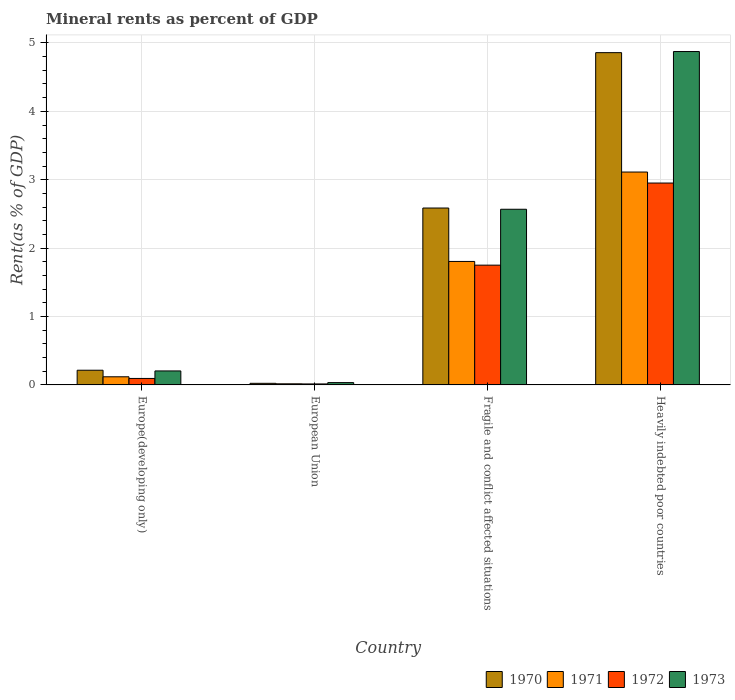How many bars are there on the 3rd tick from the left?
Your answer should be very brief. 4. What is the label of the 1st group of bars from the left?
Offer a terse response. Europe(developing only). What is the mineral rent in 1972 in Fragile and conflict affected situations?
Offer a terse response. 1.75. Across all countries, what is the maximum mineral rent in 1971?
Provide a succinct answer. 3.11. Across all countries, what is the minimum mineral rent in 1973?
Ensure brevity in your answer.  0.03. In which country was the mineral rent in 1970 maximum?
Provide a succinct answer. Heavily indebted poor countries. In which country was the mineral rent in 1972 minimum?
Make the answer very short. European Union. What is the total mineral rent in 1971 in the graph?
Make the answer very short. 5.05. What is the difference between the mineral rent in 1971 in Fragile and conflict affected situations and that in Heavily indebted poor countries?
Keep it short and to the point. -1.31. What is the difference between the mineral rent in 1970 in European Union and the mineral rent in 1972 in Europe(developing only)?
Provide a succinct answer. -0.07. What is the average mineral rent in 1973 per country?
Your response must be concise. 1.92. What is the difference between the mineral rent of/in 1971 and mineral rent of/in 1972 in Heavily indebted poor countries?
Your answer should be compact. 0.16. In how many countries, is the mineral rent in 1971 greater than 2.2 %?
Provide a short and direct response. 1. What is the ratio of the mineral rent in 1972 in Europe(developing only) to that in Heavily indebted poor countries?
Provide a succinct answer. 0.03. What is the difference between the highest and the second highest mineral rent in 1971?
Your answer should be very brief. -1.69. What is the difference between the highest and the lowest mineral rent in 1970?
Your response must be concise. 4.83. What does the 3rd bar from the left in Fragile and conflict affected situations represents?
Offer a terse response. 1972. How many bars are there?
Your response must be concise. 16. Are all the bars in the graph horizontal?
Provide a short and direct response. No. What is the difference between two consecutive major ticks on the Y-axis?
Offer a terse response. 1. Does the graph contain any zero values?
Offer a very short reply. No. Where does the legend appear in the graph?
Offer a very short reply. Bottom right. How many legend labels are there?
Provide a succinct answer. 4. What is the title of the graph?
Your response must be concise. Mineral rents as percent of GDP. Does "1996" appear as one of the legend labels in the graph?
Provide a succinct answer. No. What is the label or title of the Y-axis?
Offer a very short reply. Rent(as % of GDP). What is the Rent(as % of GDP) of 1970 in Europe(developing only)?
Your answer should be very brief. 0.21. What is the Rent(as % of GDP) of 1971 in Europe(developing only)?
Give a very brief answer. 0.12. What is the Rent(as % of GDP) of 1972 in Europe(developing only)?
Give a very brief answer. 0.09. What is the Rent(as % of GDP) of 1973 in Europe(developing only)?
Ensure brevity in your answer.  0.2. What is the Rent(as % of GDP) of 1970 in European Union?
Your answer should be very brief. 0.02. What is the Rent(as % of GDP) in 1971 in European Union?
Offer a terse response. 0.02. What is the Rent(as % of GDP) in 1972 in European Union?
Your answer should be compact. 0.01. What is the Rent(as % of GDP) of 1973 in European Union?
Ensure brevity in your answer.  0.03. What is the Rent(as % of GDP) of 1970 in Fragile and conflict affected situations?
Keep it short and to the point. 2.59. What is the Rent(as % of GDP) in 1971 in Fragile and conflict affected situations?
Keep it short and to the point. 1.81. What is the Rent(as % of GDP) in 1972 in Fragile and conflict affected situations?
Offer a terse response. 1.75. What is the Rent(as % of GDP) of 1973 in Fragile and conflict affected situations?
Keep it short and to the point. 2.57. What is the Rent(as % of GDP) in 1970 in Heavily indebted poor countries?
Keep it short and to the point. 4.86. What is the Rent(as % of GDP) of 1971 in Heavily indebted poor countries?
Provide a short and direct response. 3.11. What is the Rent(as % of GDP) in 1972 in Heavily indebted poor countries?
Provide a short and direct response. 2.95. What is the Rent(as % of GDP) of 1973 in Heavily indebted poor countries?
Your answer should be very brief. 4.87. Across all countries, what is the maximum Rent(as % of GDP) in 1970?
Your answer should be compact. 4.86. Across all countries, what is the maximum Rent(as % of GDP) of 1971?
Give a very brief answer. 3.11. Across all countries, what is the maximum Rent(as % of GDP) of 1972?
Offer a terse response. 2.95. Across all countries, what is the maximum Rent(as % of GDP) of 1973?
Your answer should be compact. 4.87. Across all countries, what is the minimum Rent(as % of GDP) in 1970?
Keep it short and to the point. 0.02. Across all countries, what is the minimum Rent(as % of GDP) in 1971?
Offer a very short reply. 0.02. Across all countries, what is the minimum Rent(as % of GDP) in 1972?
Make the answer very short. 0.01. Across all countries, what is the minimum Rent(as % of GDP) of 1973?
Keep it short and to the point. 0.03. What is the total Rent(as % of GDP) of 1970 in the graph?
Your answer should be very brief. 7.68. What is the total Rent(as % of GDP) in 1971 in the graph?
Keep it short and to the point. 5.05. What is the total Rent(as % of GDP) of 1972 in the graph?
Offer a very short reply. 4.81. What is the total Rent(as % of GDP) in 1973 in the graph?
Make the answer very short. 7.68. What is the difference between the Rent(as % of GDP) in 1970 in Europe(developing only) and that in European Union?
Keep it short and to the point. 0.19. What is the difference between the Rent(as % of GDP) in 1971 in Europe(developing only) and that in European Union?
Give a very brief answer. 0.1. What is the difference between the Rent(as % of GDP) in 1972 in Europe(developing only) and that in European Union?
Your answer should be compact. 0.08. What is the difference between the Rent(as % of GDP) in 1973 in Europe(developing only) and that in European Union?
Your answer should be very brief. 0.17. What is the difference between the Rent(as % of GDP) of 1970 in Europe(developing only) and that in Fragile and conflict affected situations?
Provide a short and direct response. -2.37. What is the difference between the Rent(as % of GDP) in 1971 in Europe(developing only) and that in Fragile and conflict affected situations?
Offer a terse response. -1.69. What is the difference between the Rent(as % of GDP) in 1972 in Europe(developing only) and that in Fragile and conflict affected situations?
Make the answer very short. -1.66. What is the difference between the Rent(as % of GDP) of 1973 in Europe(developing only) and that in Fragile and conflict affected situations?
Offer a very short reply. -2.36. What is the difference between the Rent(as % of GDP) of 1970 in Europe(developing only) and that in Heavily indebted poor countries?
Make the answer very short. -4.64. What is the difference between the Rent(as % of GDP) of 1971 in Europe(developing only) and that in Heavily indebted poor countries?
Offer a very short reply. -2.99. What is the difference between the Rent(as % of GDP) of 1972 in Europe(developing only) and that in Heavily indebted poor countries?
Your answer should be very brief. -2.86. What is the difference between the Rent(as % of GDP) in 1973 in Europe(developing only) and that in Heavily indebted poor countries?
Keep it short and to the point. -4.67. What is the difference between the Rent(as % of GDP) of 1970 in European Union and that in Fragile and conflict affected situations?
Provide a short and direct response. -2.56. What is the difference between the Rent(as % of GDP) in 1971 in European Union and that in Fragile and conflict affected situations?
Provide a short and direct response. -1.79. What is the difference between the Rent(as % of GDP) in 1972 in European Union and that in Fragile and conflict affected situations?
Provide a succinct answer. -1.74. What is the difference between the Rent(as % of GDP) in 1973 in European Union and that in Fragile and conflict affected situations?
Give a very brief answer. -2.53. What is the difference between the Rent(as % of GDP) of 1970 in European Union and that in Heavily indebted poor countries?
Provide a succinct answer. -4.83. What is the difference between the Rent(as % of GDP) of 1971 in European Union and that in Heavily indebted poor countries?
Your response must be concise. -3.1. What is the difference between the Rent(as % of GDP) in 1972 in European Union and that in Heavily indebted poor countries?
Offer a terse response. -2.94. What is the difference between the Rent(as % of GDP) of 1973 in European Union and that in Heavily indebted poor countries?
Offer a very short reply. -4.84. What is the difference between the Rent(as % of GDP) of 1970 in Fragile and conflict affected situations and that in Heavily indebted poor countries?
Your response must be concise. -2.27. What is the difference between the Rent(as % of GDP) of 1971 in Fragile and conflict affected situations and that in Heavily indebted poor countries?
Your answer should be very brief. -1.31. What is the difference between the Rent(as % of GDP) in 1972 in Fragile and conflict affected situations and that in Heavily indebted poor countries?
Offer a very short reply. -1.2. What is the difference between the Rent(as % of GDP) in 1973 in Fragile and conflict affected situations and that in Heavily indebted poor countries?
Your answer should be compact. -2.31. What is the difference between the Rent(as % of GDP) in 1970 in Europe(developing only) and the Rent(as % of GDP) in 1971 in European Union?
Provide a succinct answer. 0.2. What is the difference between the Rent(as % of GDP) of 1970 in Europe(developing only) and the Rent(as % of GDP) of 1972 in European Union?
Give a very brief answer. 0.2. What is the difference between the Rent(as % of GDP) of 1970 in Europe(developing only) and the Rent(as % of GDP) of 1973 in European Union?
Offer a terse response. 0.18. What is the difference between the Rent(as % of GDP) of 1971 in Europe(developing only) and the Rent(as % of GDP) of 1972 in European Union?
Provide a succinct answer. 0.1. What is the difference between the Rent(as % of GDP) in 1971 in Europe(developing only) and the Rent(as % of GDP) in 1973 in European Union?
Provide a short and direct response. 0.09. What is the difference between the Rent(as % of GDP) of 1972 in Europe(developing only) and the Rent(as % of GDP) of 1973 in European Union?
Your answer should be very brief. 0.06. What is the difference between the Rent(as % of GDP) of 1970 in Europe(developing only) and the Rent(as % of GDP) of 1971 in Fragile and conflict affected situations?
Your answer should be compact. -1.59. What is the difference between the Rent(as % of GDP) of 1970 in Europe(developing only) and the Rent(as % of GDP) of 1972 in Fragile and conflict affected situations?
Your answer should be compact. -1.54. What is the difference between the Rent(as % of GDP) of 1970 in Europe(developing only) and the Rent(as % of GDP) of 1973 in Fragile and conflict affected situations?
Your answer should be very brief. -2.35. What is the difference between the Rent(as % of GDP) of 1971 in Europe(developing only) and the Rent(as % of GDP) of 1972 in Fragile and conflict affected situations?
Give a very brief answer. -1.63. What is the difference between the Rent(as % of GDP) of 1971 in Europe(developing only) and the Rent(as % of GDP) of 1973 in Fragile and conflict affected situations?
Your answer should be compact. -2.45. What is the difference between the Rent(as % of GDP) in 1972 in Europe(developing only) and the Rent(as % of GDP) in 1973 in Fragile and conflict affected situations?
Your answer should be very brief. -2.47. What is the difference between the Rent(as % of GDP) in 1970 in Europe(developing only) and the Rent(as % of GDP) in 1971 in Heavily indebted poor countries?
Provide a succinct answer. -2.9. What is the difference between the Rent(as % of GDP) in 1970 in Europe(developing only) and the Rent(as % of GDP) in 1972 in Heavily indebted poor countries?
Provide a succinct answer. -2.74. What is the difference between the Rent(as % of GDP) of 1970 in Europe(developing only) and the Rent(as % of GDP) of 1973 in Heavily indebted poor countries?
Provide a succinct answer. -4.66. What is the difference between the Rent(as % of GDP) in 1971 in Europe(developing only) and the Rent(as % of GDP) in 1972 in Heavily indebted poor countries?
Your response must be concise. -2.83. What is the difference between the Rent(as % of GDP) of 1971 in Europe(developing only) and the Rent(as % of GDP) of 1973 in Heavily indebted poor countries?
Keep it short and to the point. -4.76. What is the difference between the Rent(as % of GDP) of 1972 in Europe(developing only) and the Rent(as % of GDP) of 1973 in Heavily indebted poor countries?
Offer a terse response. -4.78. What is the difference between the Rent(as % of GDP) in 1970 in European Union and the Rent(as % of GDP) in 1971 in Fragile and conflict affected situations?
Offer a terse response. -1.78. What is the difference between the Rent(as % of GDP) in 1970 in European Union and the Rent(as % of GDP) in 1972 in Fragile and conflict affected situations?
Offer a very short reply. -1.73. What is the difference between the Rent(as % of GDP) in 1970 in European Union and the Rent(as % of GDP) in 1973 in Fragile and conflict affected situations?
Offer a very short reply. -2.54. What is the difference between the Rent(as % of GDP) of 1971 in European Union and the Rent(as % of GDP) of 1972 in Fragile and conflict affected situations?
Offer a very short reply. -1.73. What is the difference between the Rent(as % of GDP) in 1971 in European Union and the Rent(as % of GDP) in 1973 in Fragile and conflict affected situations?
Provide a short and direct response. -2.55. What is the difference between the Rent(as % of GDP) in 1972 in European Union and the Rent(as % of GDP) in 1973 in Fragile and conflict affected situations?
Your answer should be very brief. -2.55. What is the difference between the Rent(as % of GDP) of 1970 in European Union and the Rent(as % of GDP) of 1971 in Heavily indebted poor countries?
Ensure brevity in your answer.  -3.09. What is the difference between the Rent(as % of GDP) in 1970 in European Union and the Rent(as % of GDP) in 1972 in Heavily indebted poor countries?
Your response must be concise. -2.93. What is the difference between the Rent(as % of GDP) of 1970 in European Union and the Rent(as % of GDP) of 1973 in Heavily indebted poor countries?
Ensure brevity in your answer.  -4.85. What is the difference between the Rent(as % of GDP) of 1971 in European Union and the Rent(as % of GDP) of 1972 in Heavily indebted poor countries?
Offer a terse response. -2.94. What is the difference between the Rent(as % of GDP) in 1971 in European Union and the Rent(as % of GDP) in 1973 in Heavily indebted poor countries?
Your answer should be compact. -4.86. What is the difference between the Rent(as % of GDP) in 1972 in European Union and the Rent(as % of GDP) in 1973 in Heavily indebted poor countries?
Give a very brief answer. -4.86. What is the difference between the Rent(as % of GDP) in 1970 in Fragile and conflict affected situations and the Rent(as % of GDP) in 1971 in Heavily indebted poor countries?
Ensure brevity in your answer.  -0.53. What is the difference between the Rent(as % of GDP) of 1970 in Fragile and conflict affected situations and the Rent(as % of GDP) of 1972 in Heavily indebted poor countries?
Provide a short and direct response. -0.37. What is the difference between the Rent(as % of GDP) in 1970 in Fragile and conflict affected situations and the Rent(as % of GDP) in 1973 in Heavily indebted poor countries?
Make the answer very short. -2.29. What is the difference between the Rent(as % of GDP) in 1971 in Fragile and conflict affected situations and the Rent(as % of GDP) in 1972 in Heavily indebted poor countries?
Offer a very short reply. -1.15. What is the difference between the Rent(as % of GDP) of 1971 in Fragile and conflict affected situations and the Rent(as % of GDP) of 1973 in Heavily indebted poor countries?
Offer a very short reply. -3.07. What is the difference between the Rent(as % of GDP) of 1972 in Fragile and conflict affected situations and the Rent(as % of GDP) of 1973 in Heavily indebted poor countries?
Offer a terse response. -3.12. What is the average Rent(as % of GDP) in 1970 per country?
Offer a very short reply. 1.92. What is the average Rent(as % of GDP) in 1971 per country?
Ensure brevity in your answer.  1.26. What is the average Rent(as % of GDP) of 1972 per country?
Provide a short and direct response. 1.2. What is the average Rent(as % of GDP) of 1973 per country?
Provide a short and direct response. 1.92. What is the difference between the Rent(as % of GDP) of 1970 and Rent(as % of GDP) of 1971 in Europe(developing only)?
Offer a terse response. 0.1. What is the difference between the Rent(as % of GDP) of 1970 and Rent(as % of GDP) of 1972 in Europe(developing only)?
Ensure brevity in your answer.  0.12. What is the difference between the Rent(as % of GDP) in 1970 and Rent(as % of GDP) in 1973 in Europe(developing only)?
Provide a short and direct response. 0.01. What is the difference between the Rent(as % of GDP) of 1971 and Rent(as % of GDP) of 1972 in Europe(developing only)?
Offer a terse response. 0.02. What is the difference between the Rent(as % of GDP) of 1971 and Rent(as % of GDP) of 1973 in Europe(developing only)?
Offer a terse response. -0.09. What is the difference between the Rent(as % of GDP) in 1972 and Rent(as % of GDP) in 1973 in Europe(developing only)?
Your answer should be very brief. -0.11. What is the difference between the Rent(as % of GDP) of 1970 and Rent(as % of GDP) of 1971 in European Union?
Your response must be concise. 0.01. What is the difference between the Rent(as % of GDP) in 1970 and Rent(as % of GDP) in 1972 in European Union?
Your answer should be compact. 0.01. What is the difference between the Rent(as % of GDP) in 1970 and Rent(as % of GDP) in 1973 in European Union?
Keep it short and to the point. -0.01. What is the difference between the Rent(as % of GDP) in 1971 and Rent(as % of GDP) in 1972 in European Union?
Your answer should be very brief. 0. What is the difference between the Rent(as % of GDP) in 1971 and Rent(as % of GDP) in 1973 in European Union?
Your answer should be very brief. -0.02. What is the difference between the Rent(as % of GDP) of 1972 and Rent(as % of GDP) of 1973 in European Union?
Offer a very short reply. -0.02. What is the difference between the Rent(as % of GDP) of 1970 and Rent(as % of GDP) of 1971 in Fragile and conflict affected situations?
Offer a very short reply. 0.78. What is the difference between the Rent(as % of GDP) of 1970 and Rent(as % of GDP) of 1972 in Fragile and conflict affected situations?
Provide a succinct answer. 0.84. What is the difference between the Rent(as % of GDP) in 1970 and Rent(as % of GDP) in 1973 in Fragile and conflict affected situations?
Offer a very short reply. 0.02. What is the difference between the Rent(as % of GDP) in 1971 and Rent(as % of GDP) in 1972 in Fragile and conflict affected situations?
Keep it short and to the point. 0.05. What is the difference between the Rent(as % of GDP) of 1971 and Rent(as % of GDP) of 1973 in Fragile and conflict affected situations?
Provide a short and direct response. -0.76. What is the difference between the Rent(as % of GDP) of 1972 and Rent(as % of GDP) of 1973 in Fragile and conflict affected situations?
Ensure brevity in your answer.  -0.82. What is the difference between the Rent(as % of GDP) of 1970 and Rent(as % of GDP) of 1971 in Heavily indebted poor countries?
Give a very brief answer. 1.75. What is the difference between the Rent(as % of GDP) in 1970 and Rent(as % of GDP) in 1972 in Heavily indebted poor countries?
Provide a short and direct response. 1.91. What is the difference between the Rent(as % of GDP) in 1970 and Rent(as % of GDP) in 1973 in Heavily indebted poor countries?
Ensure brevity in your answer.  -0.02. What is the difference between the Rent(as % of GDP) in 1971 and Rent(as % of GDP) in 1972 in Heavily indebted poor countries?
Provide a succinct answer. 0.16. What is the difference between the Rent(as % of GDP) of 1971 and Rent(as % of GDP) of 1973 in Heavily indebted poor countries?
Provide a succinct answer. -1.76. What is the difference between the Rent(as % of GDP) of 1972 and Rent(as % of GDP) of 1973 in Heavily indebted poor countries?
Keep it short and to the point. -1.92. What is the ratio of the Rent(as % of GDP) in 1970 in Europe(developing only) to that in European Union?
Your answer should be very brief. 9.2. What is the ratio of the Rent(as % of GDP) in 1971 in Europe(developing only) to that in European Union?
Give a very brief answer. 7.31. What is the ratio of the Rent(as % of GDP) in 1972 in Europe(developing only) to that in European Union?
Offer a very short reply. 6.59. What is the ratio of the Rent(as % of GDP) of 1973 in Europe(developing only) to that in European Union?
Your response must be concise. 6.06. What is the ratio of the Rent(as % of GDP) of 1970 in Europe(developing only) to that in Fragile and conflict affected situations?
Offer a terse response. 0.08. What is the ratio of the Rent(as % of GDP) in 1971 in Europe(developing only) to that in Fragile and conflict affected situations?
Ensure brevity in your answer.  0.07. What is the ratio of the Rent(as % of GDP) in 1972 in Europe(developing only) to that in Fragile and conflict affected situations?
Your answer should be compact. 0.05. What is the ratio of the Rent(as % of GDP) in 1973 in Europe(developing only) to that in Fragile and conflict affected situations?
Keep it short and to the point. 0.08. What is the ratio of the Rent(as % of GDP) in 1970 in Europe(developing only) to that in Heavily indebted poor countries?
Keep it short and to the point. 0.04. What is the ratio of the Rent(as % of GDP) in 1971 in Europe(developing only) to that in Heavily indebted poor countries?
Your response must be concise. 0.04. What is the ratio of the Rent(as % of GDP) in 1972 in Europe(developing only) to that in Heavily indebted poor countries?
Make the answer very short. 0.03. What is the ratio of the Rent(as % of GDP) of 1973 in Europe(developing only) to that in Heavily indebted poor countries?
Offer a terse response. 0.04. What is the ratio of the Rent(as % of GDP) of 1970 in European Union to that in Fragile and conflict affected situations?
Provide a short and direct response. 0.01. What is the ratio of the Rent(as % of GDP) in 1971 in European Union to that in Fragile and conflict affected situations?
Your answer should be very brief. 0.01. What is the ratio of the Rent(as % of GDP) in 1972 in European Union to that in Fragile and conflict affected situations?
Offer a very short reply. 0.01. What is the ratio of the Rent(as % of GDP) in 1973 in European Union to that in Fragile and conflict affected situations?
Your answer should be compact. 0.01. What is the ratio of the Rent(as % of GDP) in 1970 in European Union to that in Heavily indebted poor countries?
Your answer should be very brief. 0. What is the ratio of the Rent(as % of GDP) of 1971 in European Union to that in Heavily indebted poor countries?
Provide a succinct answer. 0.01. What is the ratio of the Rent(as % of GDP) in 1972 in European Union to that in Heavily indebted poor countries?
Ensure brevity in your answer.  0. What is the ratio of the Rent(as % of GDP) in 1973 in European Union to that in Heavily indebted poor countries?
Make the answer very short. 0.01. What is the ratio of the Rent(as % of GDP) of 1970 in Fragile and conflict affected situations to that in Heavily indebted poor countries?
Offer a terse response. 0.53. What is the ratio of the Rent(as % of GDP) of 1971 in Fragile and conflict affected situations to that in Heavily indebted poor countries?
Give a very brief answer. 0.58. What is the ratio of the Rent(as % of GDP) in 1972 in Fragile and conflict affected situations to that in Heavily indebted poor countries?
Your response must be concise. 0.59. What is the ratio of the Rent(as % of GDP) of 1973 in Fragile and conflict affected situations to that in Heavily indebted poor countries?
Make the answer very short. 0.53. What is the difference between the highest and the second highest Rent(as % of GDP) of 1970?
Give a very brief answer. 2.27. What is the difference between the highest and the second highest Rent(as % of GDP) of 1971?
Offer a terse response. 1.31. What is the difference between the highest and the second highest Rent(as % of GDP) in 1972?
Ensure brevity in your answer.  1.2. What is the difference between the highest and the second highest Rent(as % of GDP) in 1973?
Provide a succinct answer. 2.31. What is the difference between the highest and the lowest Rent(as % of GDP) in 1970?
Give a very brief answer. 4.83. What is the difference between the highest and the lowest Rent(as % of GDP) of 1971?
Your answer should be very brief. 3.1. What is the difference between the highest and the lowest Rent(as % of GDP) in 1972?
Your answer should be compact. 2.94. What is the difference between the highest and the lowest Rent(as % of GDP) in 1973?
Keep it short and to the point. 4.84. 